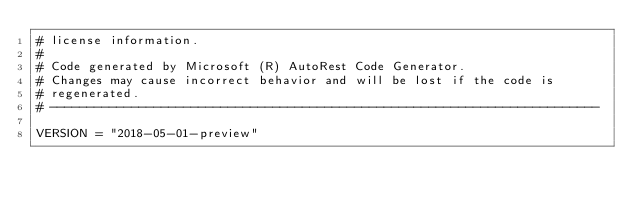Convert code to text. <code><loc_0><loc_0><loc_500><loc_500><_Python_># license information.
#
# Code generated by Microsoft (R) AutoRest Code Generator.
# Changes may cause incorrect behavior and will be lost if the code is
# regenerated.
# --------------------------------------------------------------------------

VERSION = "2018-05-01-preview"

</code> 